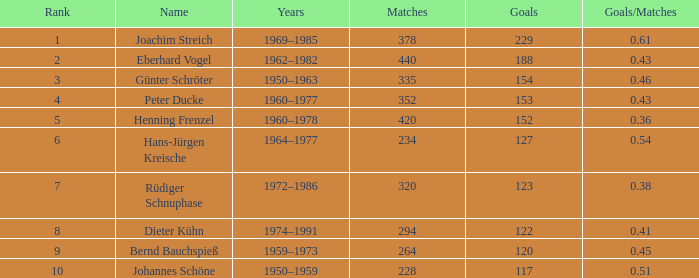How many goals/matches have 153 as the goals with matches greater than 352? None. 